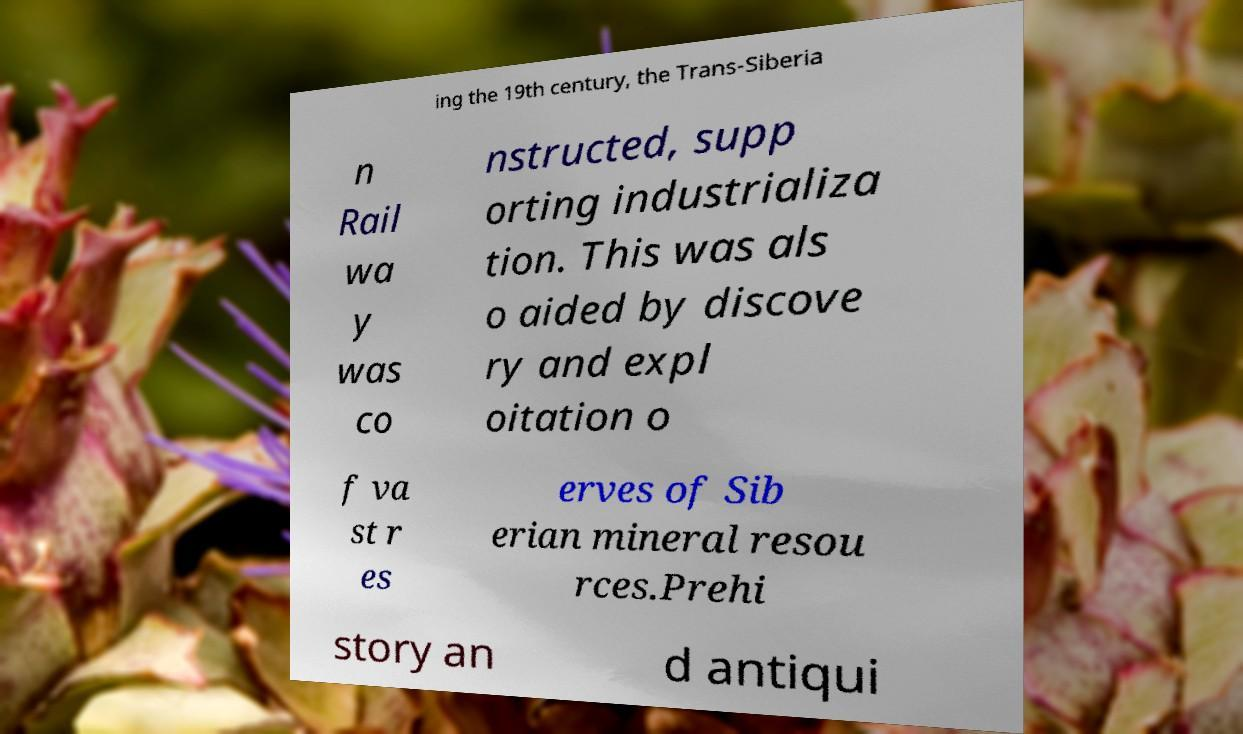Can you read and provide the text displayed in the image?This photo seems to have some interesting text. Can you extract and type it out for me? ing the 19th century, the Trans-Siberia n Rail wa y was co nstructed, supp orting industrializa tion. This was als o aided by discove ry and expl oitation o f va st r es erves of Sib erian mineral resou rces.Prehi story an d antiqui 